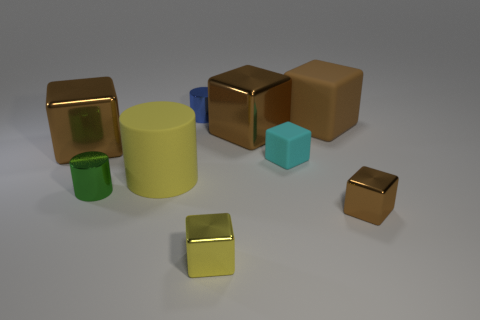There is a brown cube that is to the right of the small cyan object and behind the small rubber cube; what is its material? The brown cube positioned to the right of the small cyan object and behind the small rubber cube appears to be made of a shiny, metallic material, differing from the matte texture of rubber. 